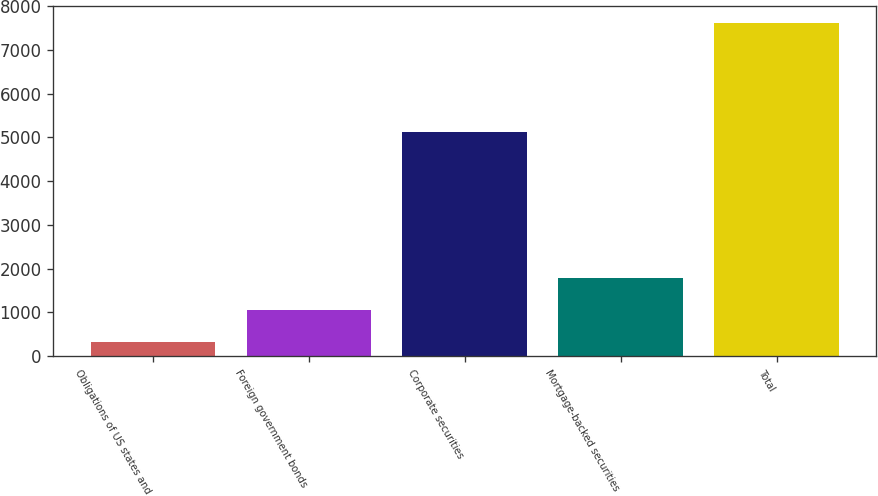Convert chart. <chart><loc_0><loc_0><loc_500><loc_500><bar_chart><fcel>Obligations of US states and<fcel>Foreign government bonds<fcel>Corporate securities<fcel>Mortgage-backed securities<fcel>Total<nl><fcel>331<fcel>1059.9<fcel>5131<fcel>1788.8<fcel>7620<nl></chart> 